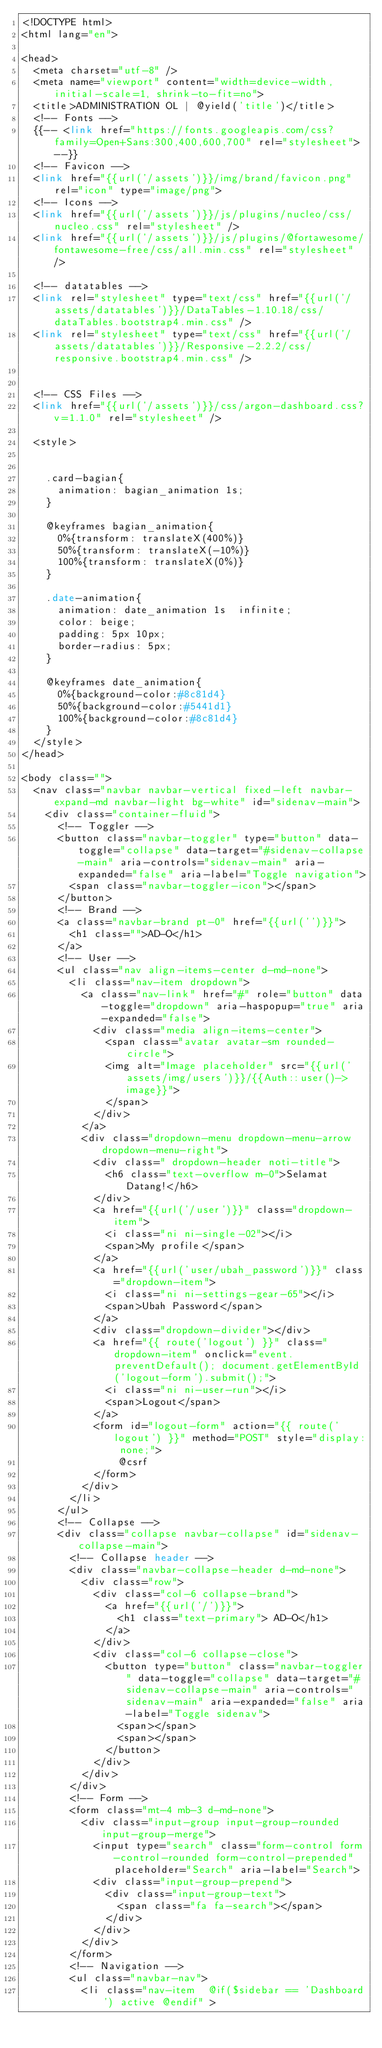<code> <loc_0><loc_0><loc_500><loc_500><_PHP_><!DOCTYPE html>
<html lang="en">

<head>
  <meta charset="utf-8" />
  <meta name="viewport" content="width=device-width, initial-scale=1, shrink-to-fit=no">
  <title>ADMINISTRATION OL | @yield('title')</title>
  <!-- Fonts -->
  {{-- <link href="https://fonts.googleapis.com/css?family=Open+Sans:300,400,600,700" rel="stylesheet"> --}}
  <!-- Favicon -->
  <link href="{{url('/assets')}}/img/brand/favicon.png" rel="icon" type="image/png">
  <!-- Icons -->
  <link href="{{url('/assets')}}/js/plugins/nucleo/css/nucleo.css" rel="stylesheet" />
  <link href="{{url('/assets')}}/js/plugins/@fortawesome/fontawesome-free/css/all.min.css" rel="stylesheet" />

  <!-- datatables -->
  <link rel="stylesheet" type="text/css" href="{{url('/assets/datatables')}}/DataTables-1.10.18/css/dataTables.bootstrap4.min.css" />
  <link rel="stylesheet" type="text/css" href="{{url('/assets/datatables')}}/Responsive-2.2.2/css/responsive.bootstrap4.min.css" />


  <!-- CSS Files -->
  <link href="{{url('/assets')}}/css/argon-dashboard.css?v=1.1.0" rel="stylesheet" />

  <style>


    .card-bagian{
      animation: bagian_animation 1s;
    }

    @keyframes bagian_animation{
      0%{transform: translateX(400%)}
      50%{transform: translateX(-10%)}
      100%{transform: translateX(0%)}
    }
    
    .date-animation{
      animation: date_animation 1s  infinite;
      color: beige;
      padding: 5px 10px;
      border-radius: 5px;
    }

    @keyframes date_animation{
      0%{background-color:#8c81d4}
      50%{background-color:#5441d1}
      100%{background-color:#8c81d4}
    }
  </style>
</head>

<body class="">
  <nav class="navbar navbar-vertical fixed-left navbar-expand-md navbar-light bg-white" id="sidenav-main">
    <div class="container-fluid">
      <!-- Toggler -->
      <button class="navbar-toggler" type="button" data-toggle="collapse" data-target="#sidenav-collapse-main" aria-controls="sidenav-main" aria-expanded="false" aria-label="Toggle navigation">
        <span class="navbar-toggler-icon"></span>
      </button>
      <!-- Brand -->
      <a class="navbar-brand pt-0" href="{{url('')}}">
        <h1 class="">AD-O</h1>
      </a>
      <!-- User -->
      <ul class="nav align-items-center d-md-none">
        <li class="nav-item dropdown">
          <a class="nav-link" href="#" role="button" data-toggle="dropdown" aria-haspopup="true" aria-expanded="false">
            <div class="media align-items-center">
              <span class="avatar avatar-sm rounded-circle">
              <img alt="Image placeholder" src="{{url('assets/img/users')}}/{{Auth::user()->image}}">
              </span>
            </div>
          </a>
          <div class="dropdown-menu dropdown-menu-arrow dropdown-menu-right">
            <div class=" dropdown-header noti-title">
              <h6 class="text-overflow m-0">Selamat Datang!</h6>
            </div>
            <a href="{{url('/user')}}" class="dropdown-item">
              <i class="ni ni-single-02"></i>
              <span>My profile</span>
            </a>
            <a href="{{url('user/ubah_password')}}" class="dropdown-item">
              <i class="ni ni-settings-gear-65"></i>
              <span>Ubah Password</span>
            </a>
            <div class="dropdown-divider"></div>
            <a href="{{ route('logout') }}" class="dropdown-item" onclick="event.preventDefault(); document.getElementById('logout-form').submit();">
              <i class="ni ni-user-run"></i>
              <span>Logout</span>
            </a>
            <form id="logout-form" action="{{ route('logout') }}" method="POST" style="display: none;">
                @csrf
            </form>
          </div>
        </li>
      </ul>
      <!-- Collapse -->
      <div class="collapse navbar-collapse" id="sidenav-collapse-main">
        <!-- Collapse header -->
        <div class="navbar-collapse-header d-md-none">
          <div class="row">
            <div class="col-6 collapse-brand">
              <a href="{{url('/')}}">
                <h1 class="text-primary"> AD-O</h1>
              </a>
            </div>
            <div class="col-6 collapse-close">
              <button type="button" class="navbar-toggler" data-toggle="collapse" data-target="#sidenav-collapse-main" aria-controls="sidenav-main" aria-expanded="false" aria-label="Toggle sidenav">
                <span></span>
                <span></span>
              </button>
            </div>
          </div>
        </div>
        <!-- Form -->
        <form class="mt-4 mb-3 d-md-none">
          <div class="input-group input-group-rounded input-group-merge">
            <input type="search" class="form-control form-control-rounded form-control-prepended" placeholder="Search" aria-label="Search">
            <div class="input-group-prepend">
              <div class="input-group-text">
                <span class="fa fa-search"></span>
              </div>
            </div>
          </div>
        </form>
        <!-- Navigation -->
        <ul class="navbar-nav">
          <li class="nav-item  @if($sidebar == 'Dashboard') active @endif" ></code> 